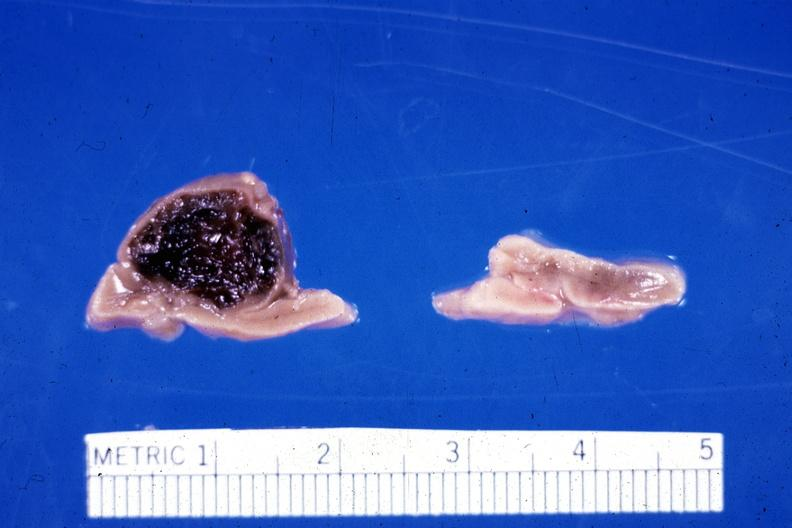s hemorrhage in newborn present?
Answer the question using a single word or phrase. Yes 